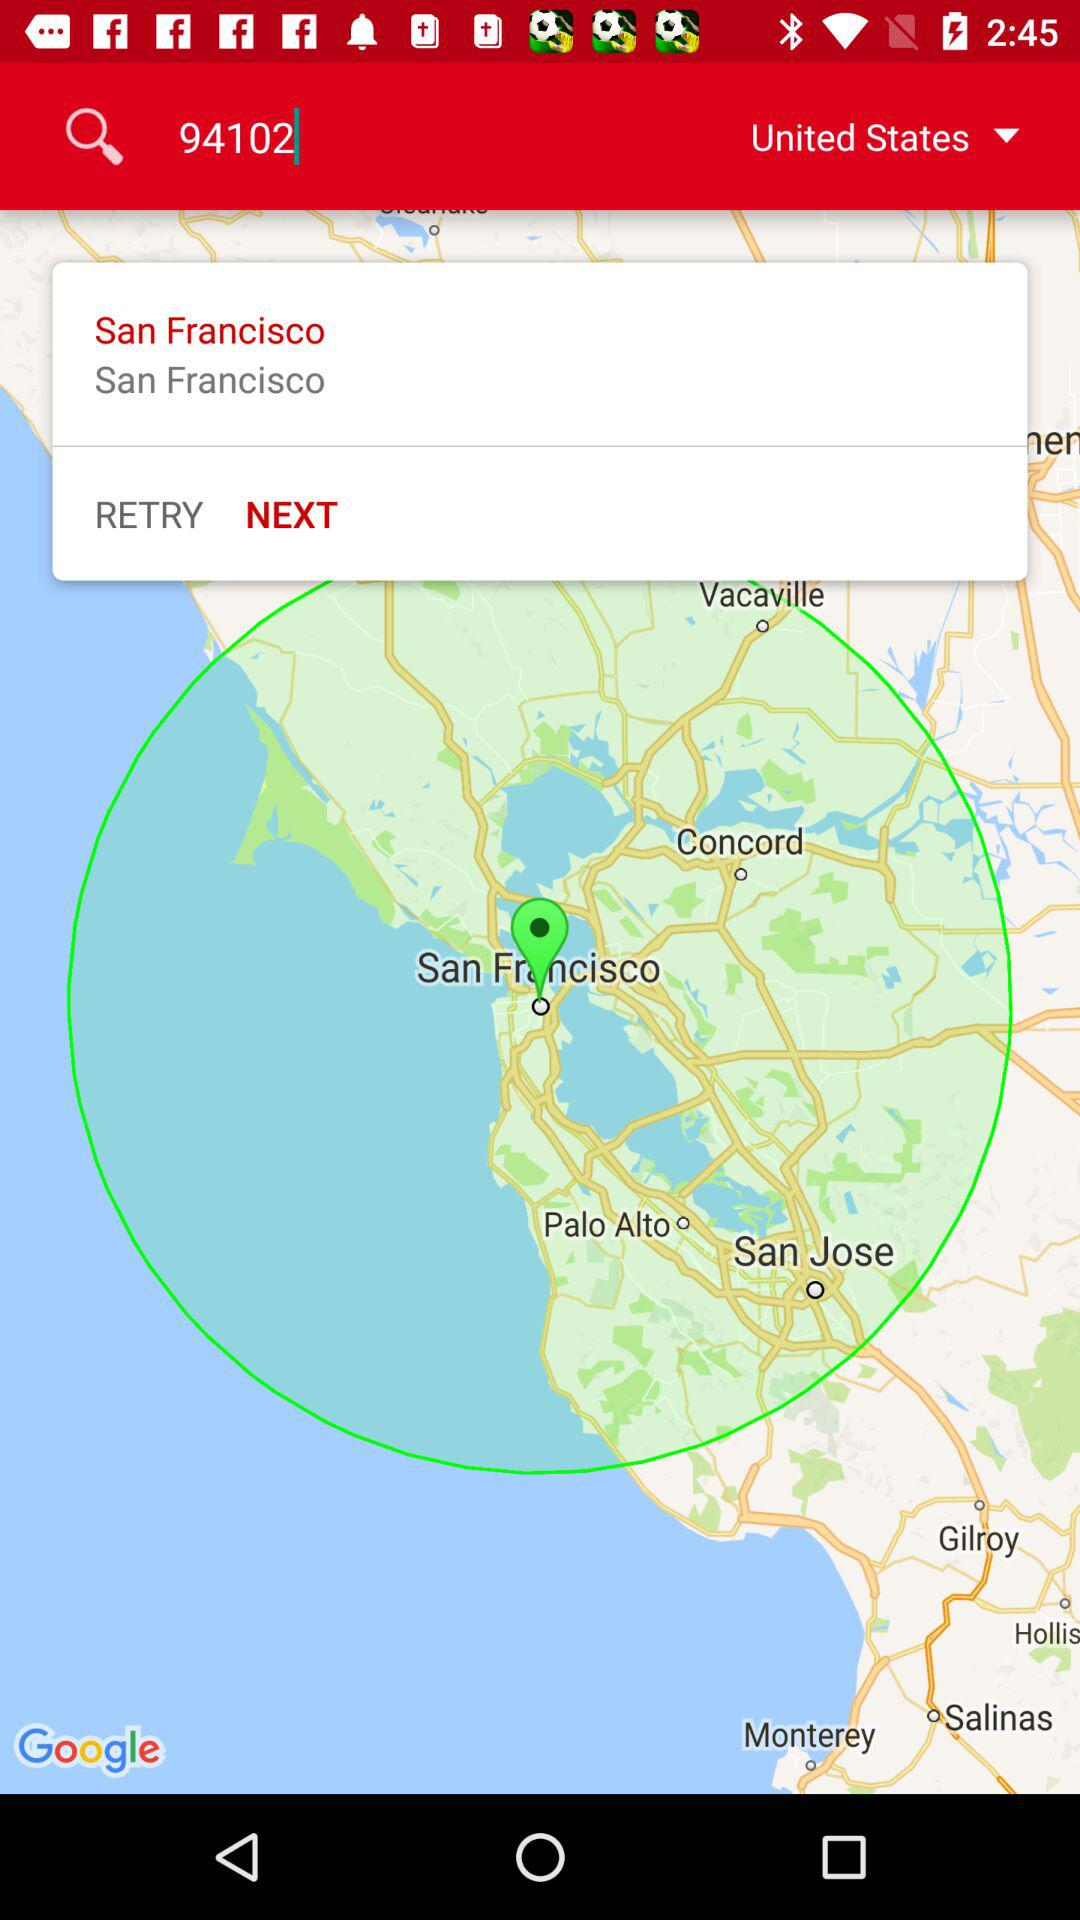What is the entered number? The entered number is 94102. 